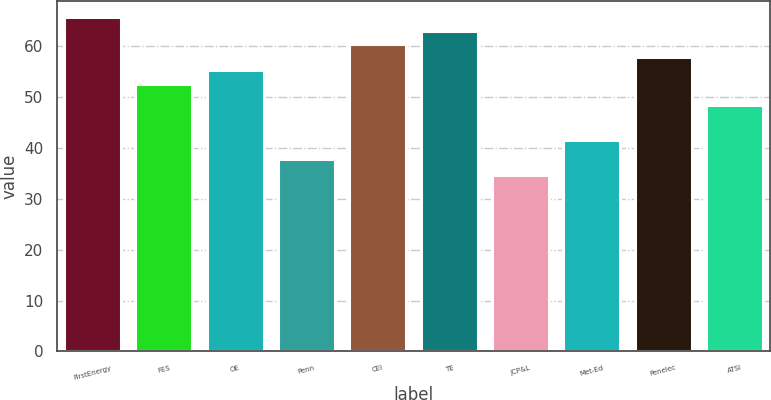Convert chart to OTSL. <chart><loc_0><loc_0><loc_500><loc_500><bar_chart><fcel>FirstEnergy<fcel>FES<fcel>OE<fcel>Penn<fcel>CEI<fcel>TE<fcel>JCP&L<fcel>Met-Ed<fcel>Penelec<fcel>ATSI<nl><fcel>65.6<fcel>52.6<fcel>55.2<fcel>37.7<fcel>60.4<fcel>63<fcel>34.6<fcel>41.5<fcel>57.8<fcel>48.3<nl></chart> 